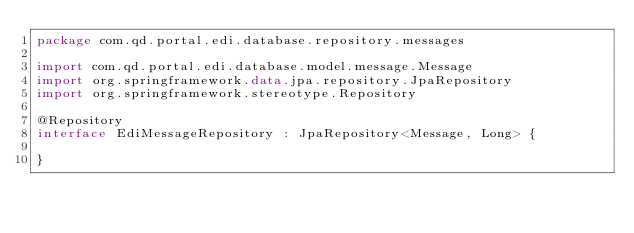Convert code to text. <code><loc_0><loc_0><loc_500><loc_500><_Kotlin_>package com.qd.portal.edi.database.repository.messages

import com.qd.portal.edi.database.model.message.Message
import org.springframework.data.jpa.repository.JpaRepository
import org.springframework.stereotype.Repository

@Repository
interface EdiMessageRepository : JpaRepository<Message, Long> {

}</code> 